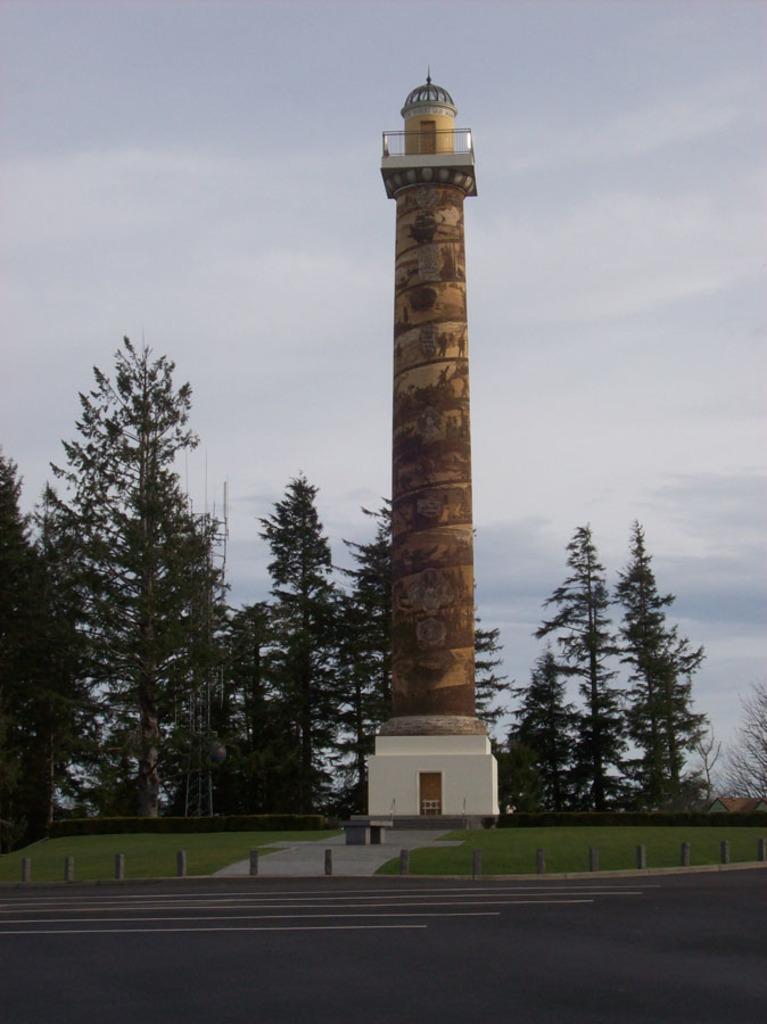How would you summarize this image in a sentence or two? This picture shows a tower and we see trees and grass on the ground and we see a road and a cloudy sky. 